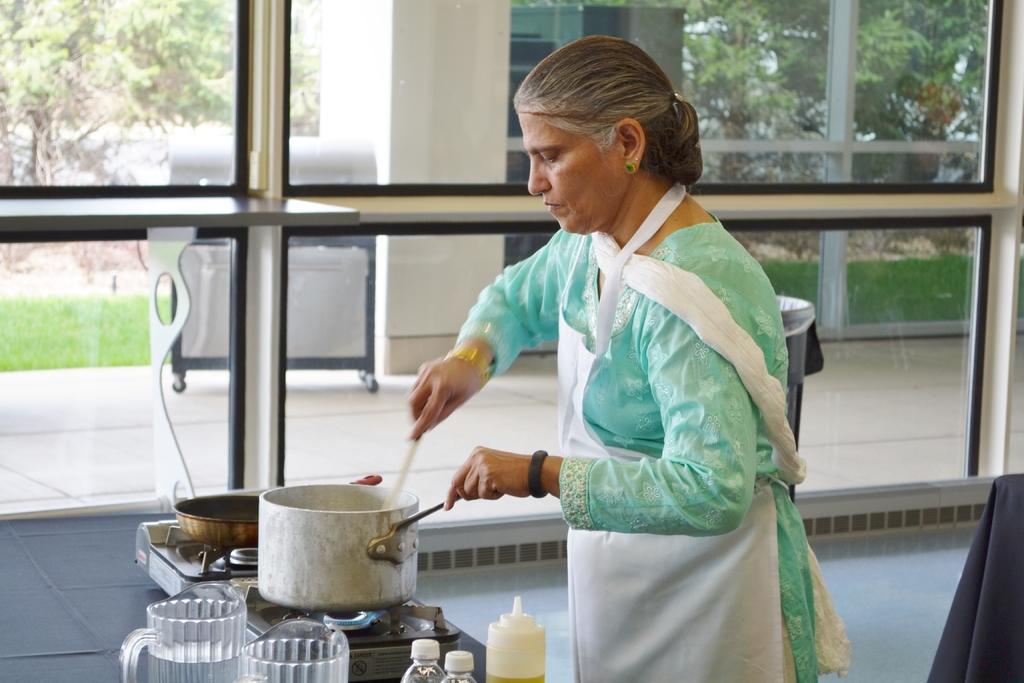How would you summarize this image in a sentence or two? A woman is cooking on this stove, she wore green color dress. This is the glass wall, outside this there are trees. 